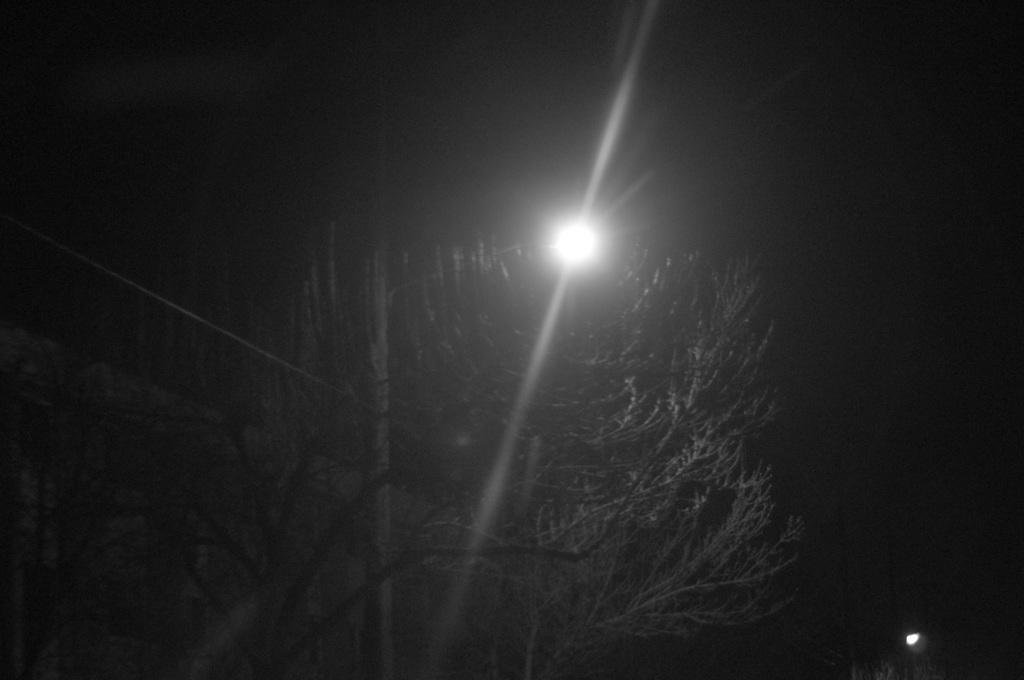What time of day was the image taken? The image was taken during night time. What type of natural elements can be seen in the image? There are trees visible in the image. What artificial elements can be seen in the image? There are lights visible in the image. What type of pain is the tree experiencing in the image? There is no indication in the image that the tree is experiencing any pain. 